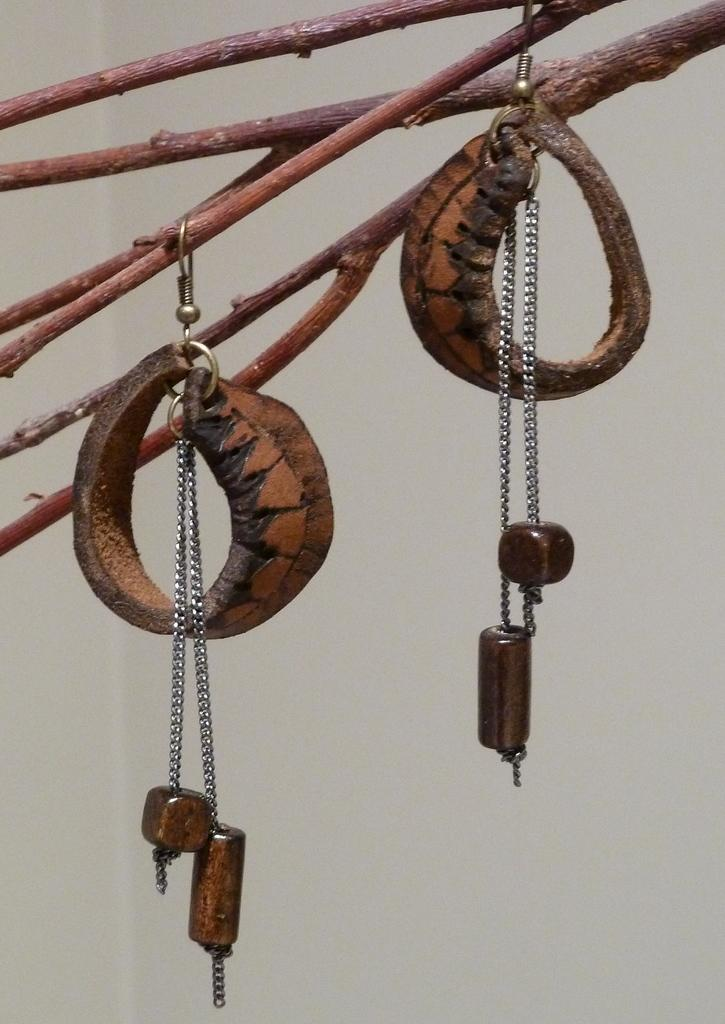What is located in the middle of the image? There is a chain and lockets in the middle of the image. Can you describe the chain in the image? The chain is in the middle of the image. What are the lockets like in the image? The lockets are also in the middle of the image. How does the chain help with the payment process in the image? The image does not depict any payment process, and the chain is not related to any such activity. What type of glue is used to attach the lockets to the chain in the image? There is no indication in the image that any glue is used to attach the lockets to the chain. 